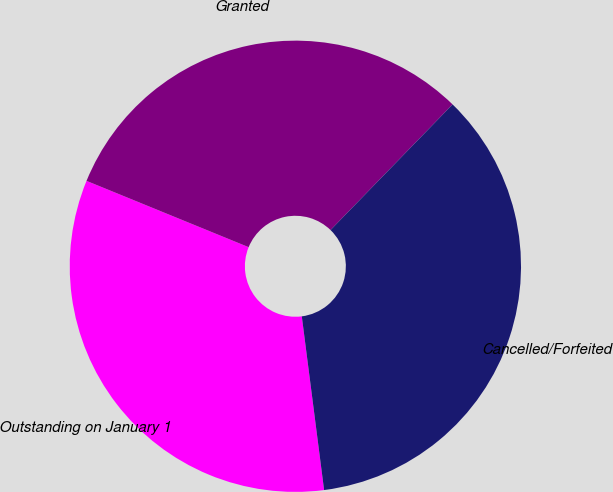Convert chart to OTSL. <chart><loc_0><loc_0><loc_500><loc_500><pie_chart><fcel>Outstanding on January 1<fcel>Granted<fcel>Cancelled/Forfeited<nl><fcel>33.21%<fcel>31.09%<fcel>35.7%<nl></chart> 